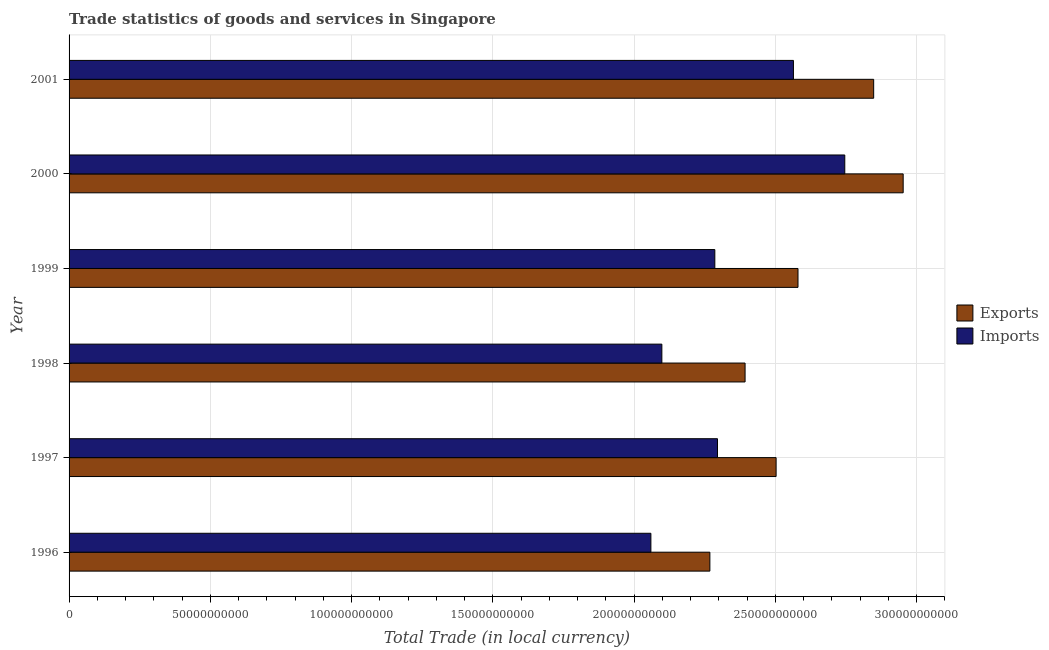How many different coloured bars are there?
Your answer should be very brief. 2. How many groups of bars are there?
Make the answer very short. 6. What is the imports of goods and services in 2000?
Ensure brevity in your answer.  2.75e+11. Across all years, what is the maximum export of goods and services?
Your response must be concise. 2.95e+11. Across all years, what is the minimum export of goods and services?
Offer a very short reply. 2.27e+11. In which year was the imports of goods and services maximum?
Your answer should be very brief. 2000. In which year was the imports of goods and services minimum?
Give a very brief answer. 1996. What is the total export of goods and services in the graph?
Your answer should be very brief. 1.55e+12. What is the difference between the imports of goods and services in 1998 and that in 2000?
Offer a very short reply. -6.47e+1. What is the difference between the imports of goods and services in 1999 and the export of goods and services in 1996?
Your response must be concise. 1.75e+09. What is the average export of goods and services per year?
Make the answer very short. 2.59e+11. In the year 1998, what is the difference between the imports of goods and services and export of goods and services?
Ensure brevity in your answer.  -2.95e+1. What is the ratio of the export of goods and services in 1998 to that in 2001?
Provide a succinct answer. 0.84. What is the difference between the highest and the second highest imports of goods and services?
Offer a very short reply. 1.82e+1. What is the difference between the highest and the lowest imports of goods and services?
Provide a succinct answer. 6.86e+1. In how many years, is the export of goods and services greater than the average export of goods and services taken over all years?
Provide a succinct answer. 2. Is the sum of the imports of goods and services in 1996 and 1997 greater than the maximum export of goods and services across all years?
Your answer should be compact. Yes. What does the 1st bar from the top in 2001 represents?
Offer a terse response. Imports. What does the 1st bar from the bottom in 2001 represents?
Provide a succinct answer. Exports. How many bars are there?
Make the answer very short. 12. Are all the bars in the graph horizontal?
Make the answer very short. Yes. What is the difference between two consecutive major ticks on the X-axis?
Offer a very short reply. 5.00e+1. Are the values on the major ticks of X-axis written in scientific E-notation?
Your answer should be very brief. No. Does the graph contain any zero values?
Offer a terse response. No. Does the graph contain grids?
Make the answer very short. Yes. How many legend labels are there?
Ensure brevity in your answer.  2. How are the legend labels stacked?
Make the answer very short. Vertical. What is the title of the graph?
Your answer should be very brief. Trade statistics of goods and services in Singapore. What is the label or title of the X-axis?
Offer a very short reply. Total Trade (in local currency). What is the Total Trade (in local currency) of Exports in 1996?
Provide a short and direct response. 2.27e+11. What is the Total Trade (in local currency) in Imports in 1996?
Your answer should be compact. 2.06e+11. What is the Total Trade (in local currency) in Exports in 1997?
Provide a succinct answer. 2.50e+11. What is the Total Trade (in local currency) in Imports in 1997?
Keep it short and to the point. 2.30e+11. What is the Total Trade (in local currency) of Exports in 1998?
Ensure brevity in your answer.  2.39e+11. What is the Total Trade (in local currency) in Imports in 1998?
Make the answer very short. 2.10e+11. What is the Total Trade (in local currency) in Exports in 1999?
Your response must be concise. 2.58e+11. What is the Total Trade (in local currency) of Imports in 1999?
Provide a short and direct response. 2.29e+11. What is the Total Trade (in local currency) of Exports in 2000?
Provide a short and direct response. 2.95e+11. What is the Total Trade (in local currency) of Imports in 2000?
Give a very brief answer. 2.75e+11. What is the Total Trade (in local currency) of Exports in 2001?
Offer a very short reply. 2.85e+11. What is the Total Trade (in local currency) in Imports in 2001?
Provide a short and direct response. 2.56e+11. Across all years, what is the maximum Total Trade (in local currency) of Exports?
Your response must be concise. 2.95e+11. Across all years, what is the maximum Total Trade (in local currency) in Imports?
Your response must be concise. 2.75e+11. Across all years, what is the minimum Total Trade (in local currency) in Exports?
Offer a terse response. 2.27e+11. Across all years, what is the minimum Total Trade (in local currency) in Imports?
Make the answer very short. 2.06e+11. What is the total Total Trade (in local currency) of Exports in the graph?
Keep it short and to the point. 1.55e+12. What is the total Total Trade (in local currency) in Imports in the graph?
Keep it short and to the point. 1.40e+12. What is the difference between the Total Trade (in local currency) in Exports in 1996 and that in 1997?
Offer a very short reply. -2.34e+1. What is the difference between the Total Trade (in local currency) in Imports in 1996 and that in 1997?
Provide a short and direct response. -2.36e+1. What is the difference between the Total Trade (in local currency) of Exports in 1996 and that in 1998?
Make the answer very short. -1.25e+1. What is the difference between the Total Trade (in local currency) in Imports in 1996 and that in 1998?
Provide a short and direct response. -3.88e+09. What is the difference between the Total Trade (in local currency) in Exports in 1996 and that in 1999?
Provide a short and direct response. -3.12e+1. What is the difference between the Total Trade (in local currency) in Imports in 1996 and that in 1999?
Make the answer very short. -2.26e+1. What is the difference between the Total Trade (in local currency) of Exports in 1996 and that in 2000?
Give a very brief answer. -6.84e+1. What is the difference between the Total Trade (in local currency) in Imports in 1996 and that in 2000?
Provide a short and direct response. -6.86e+1. What is the difference between the Total Trade (in local currency) of Exports in 1996 and that in 2001?
Make the answer very short. -5.80e+1. What is the difference between the Total Trade (in local currency) of Imports in 1996 and that in 2001?
Your answer should be very brief. -5.05e+1. What is the difference between the Total Trade (in local currency) in Exports in 1997 and that in 1998?
Provide a succinct answer. 1.10e+1. What is the difference between the Total Trade (in local currency) in Imports in 1997 and that in 1998?
Offer a very short reply. 1.97e+1. What is the difference between the Total Trade (in local currency) of Exports in 1997 and that in 1999?
Your answer should be compact. -7.75e+09. What is the difference between the Total Trade (in local currency) of Imports in 1997 and that in 1999?
Your answer should be compact. 9.42e+08. What is the difference between the Total Trade (in local currency) of Exports in 1997 and that in 2000?
Provide a short and direct response. -4.50e+1. What is the difference between the Total Trade (in local currency) in Imports in 1997 and that in 2000?
Provide a succinct answer. -4.51e+1. What is the difference between the Total Trade (in local currency) in Exports in 1997 and that in 2001?
Provide a short and direct response. -3.45e+1. What is the difference between the Total Trade (in local currency) of Imports in 1997 and that in 2001?
Offer a terse response. -2.69e+1. What is the difference between the Total Trade (in local currency) in Exports in 1998 and that in 1999?
Your response must be concise. -1.87e+1. What is the difference between the Total Trade (in local currency) of Imports in 1998 and that in 1999?
Your answer should be very brief. -1.87e+1. What is the difference between the Total Trade (in local currency) in Exports in 1998 and that in 2000?
Your answer should be compact. -5.60e+1. What is the difference between the Total Trade (in local currency) of Imports in 1998 and that in 2000?
Give a very brief answer. -6.47e+1. What is the difference between the Total Trade (in local currency) of Exports in 1998 and that in 2001?
Offer a very short reply. -4.55e+1. What is the difference between the Total Trade (in local currency) of Imports in 1998 and that in 2001?
Your response must be concise. -4.66e+1. What is the difference between the Total Trade (in local currency) in Exports in 1999 and that in 2000?
Provide a succinct answer. -3.72e+1. What is the difference between the Total Trade (in local currency) in Imports in 1999 and that in 2000?
Provide a succinct answer. -4.60e+1. What is the difference between the Total Trade (in local currency) of Exports in 1999 and that in 2001?
Your answer should be compact. -2.68e+1. What is the difference between the Total Trade (in local currency) in Imports in 1999 and that in 2001?
Keep it short and to the point. -2.78e+1. What is the difference between the Total Trade (in local currency) of Exports in 2000 and that in 2001?
Provide a short and direct response. 1.04e+1. What is the difference between the Total Trade (in local currency) of Imports in 2000 and that in 2001?
Your response must be concise. 1.82e+1. What is the difference between the Total Trade (in local currency) in Exports in 1996 and the Total Trade (in local currency) in Imports in 1997?
Offer a terse response. -2.70e+09. What is the difference between the Total Trade (in local currency) of Exports in 1996 and the Total Trade (in local currency) of Imports in 1998?
Provide a succinct answer. 1.70e+1. What is the difference between the Total Trade (in local currency) in Exports in 1996 and the Total Trade (in local currency) in Imports in 1999?
Provide a succinct answer. -1.75e+09. What is the difference between the Total Trade (in local currency) of Exports in 1996 and the Total Trade (in local currency) of Imports in 2000?
Offer a very short reply. -4.77e+1. What is the difference between the Total Trade (in local currency) of Exports in 1996 and the Total Trade (in local currency) of Imports in 2001?
Provide a short and direct response. -2.96e+1. What is the difference between the Total Trade (in local currency) in Exports in 1997 and the Total Trade (in local currency) in Imports in 1998?
Give a very brief answer. 4.04e+1. What is the difference between the Total Trade (in local currency) in Exports in 1997 and the Total Trade (in local currency) in Imports in 1999?
Ensure brevity in your answer.  2.17e+1. What is the difference between the Total Trade (in local currency) of Exports in 1997 and the Total Trade (in local currency) of Imports in 2000?
Your response must be concise. -2.43e+1. What is the difference between the Total Trade (in local currency) in Exports in 1997 and the Total Trade (in local currency) in Imports in 2001?
Keep it short and to the point. -6.13e+09. What is the difference between the Total Trade (in local currency) in Exports in 1998 and the Total Trade (in local currency) in Imports in 1999?
Provide a short and direct response. 1.07e+1. What is the difference between the Total Trade (in local currency) in Exports in 1998 and the Total Trade (in local currency) in Imports in 2000?
Provide a succinct answer. -3.53e+1. What is the difference between the Total Trade (in local currency) in Exports in 1998 and the Total Trade (in local currency) in Imports in 2001?
Provide a short and direct response. -1.71e+1. What is the difference between the Total Trade (in local currency) of Exports in 1999 and the Total Trade (in local currency) of Imports in 2000?
Provide a short and direct response. -1.66e+1. What is the difference between the Total Trade (in local currency) in Exports in 1999 and the Total Trade (in local currency) in Imports in 2001?
Keep it short and to the point. 1.62e+09. What is the difference between the Total Trade (in local currency) of Exports in 2000 and the Total Trade (in local currency) of Imports in 2001?
Give a very brief answer. 3.88e+1. What is the average Total Trade (in local currency) in Exports per year?
Ensure brevity in your answer.  2.59e+11. What is the average Total Trade (in local currency) of Imports per year?
Provide a succinct answer. 2.34e+11. In the year 1996, what is the difference between the Total Trade (in local currency) of Exports and Total Trade (in local currency) of Imports?
Ensure brevity in your answer.  2.09e+1. In the year 1997, what is the difference between the Total Trade (in local currency) in Exports and Total Trade (in local currency) in Imports?
Offer a very short reply. 2.07e+1. In the year 1998, what is the difference between the Total Trade (in local currency) of Exports and Total Trade (in local currency) of Imports?
Give a very brief answer. 2.95e+1. In the year 1999, what is the difference between the Total Trade (in local currency) of Exports and Total Trade (in local currency) of Imports?
Offer a very short reply. 2.94e+1. In the year 2000, what is the difference between the Total Trade (in local currency) in Exports and Total Trade (in local currency) in Imports?
Offer a very short reply. 2.07e+1. In the year 2001, what is the difference between the Total Trade (in local currency) of Exports and Total Trade (in local currency) of Imports?
Provide a succinct answer. 2.84e+1. What is the ratio of the Total Trade (in local currency) of Exports in 1996 to that in 1997?
Make the answer very short. 0.91. What is the ratio of the Total Trade (in local currency) in Imports in 1996 to that in 1997?
Your answer should be compact. 0.9. What is the ratio of the Total Trade (in local currency) in Exports in 1996 to that in 1998?
Keep it short and to the point. 0.95. What is the ratio of the Total Trade (in local currency) in Imports in 1996 to that in 1998?
Make the answer very short. 0.98. What is the ratio of the Total Trade (in local currency) in Exports in 1996 to that in 1999?
Ensure brevity in your answer.  0.88. What is the ratio of the Total Trade (in local currency) in Imports in 1996 to that in 1999?
Offer a terse response. 0.9. What is the ratio of the Total Trade (in local currency) of Exports in 1996 to that in 2000?
Ensure brevity in your answer.  0.77. What is the ratio of the Total Trade (in local currency) of Imports in 1996 to that in 2000?
Your response must be concise. 0.75. What is the ratio of the Total Trade (in local currency) of Exports in 1996 to that in 2001?
Your response must be concise. 0.8. What is the ratio of the Total Trade (in local currency) of Imports in 1996 to that in 2001?
Keep it short and to the point. 0.8. What is the ratio of the Total Trade (in local currency) of Exports in 1997 to that in 1998?
Your answer should be compact. 1.05. What is the ratio of the Total Trade (in local currency) of Imports in 1997 to that in 1998?
Offer a terse response. 1.09. What is the ratio of the Total Trade (in local currency) in Exports in 1997 to that in 1999?
Offer a terse response. 0.97. What is the ratio of the Total Trade (in local currency) in Exports in 1997 to that in 2000?
Give a very brief answer. 0.85. What is the ratio of the Total Trade (in local currency) of Imports in 1997 to that in 2000?
Give a very brief answer. 0.84. What is the ratio of the Total Trade (in local currency) of Exports in 1997 to that in 2001?
Ensure brevity in your answer.  0.88. What is the ratio of the Total Trade (in local currency) in Imports in 1997 to that in 2001?
Offer a very short reply. 0.9. What is the ratio of the Total Trade (in local currency) in Exports in 1998 to that in 1999?
Your answer should be very brief. 0.93. What is the ratio of the Total Trade (in local currency) of Imports in 1998 to that in 1999?
Provide a short and direct response. 0.92. What is the ratio of the Total Trade (in local currency) in Exports in 1998 to that in 2000?
Offer a very short reply. 0.81. What is the ratio of the Total Trade (in local currency) of Imports in 1998 to that in 2000?
Your answer should be very brief. 0.76. What is the ratio of the Total Trade (in local currency) of Exports in 1998 to that in 2001?
Ensure brevity in your answer.  0.84. What is the ratio of the Total Trade (in local currency) of Imports in 1998 to that in 2001?
Provide a succinct answer. 0.82. What is the ratio of the Total Trade (in local currency) of Exports in 1999 to that in 2000?
Offer a very short reply. 0.87. What is the ratio of the Total Trade (in local currency) in Imports in 1999 to that in 2000?
Make the answer very short. 0.83. What is the ratio of the Total Trade (in local currency) of Exports in 1999 to that in 2001?
Give a very brief answer. 0.91. What is the ratio of the Total Trade (in local currency) of Imports in 1999 to that in 2001?
Your answer should be very brief. 0.89. What is the ratio of the Total Trade (in local currency) in Exports in 2000 to that in 2001?
Offer a terse response. 1.04. What is the ratio of the Total Trade (in local currency) of Imports in 2000 to that in 2001?
Your answer should be very brief. 1.07. What is the difference between the highest and the second highest Total Trade (in local currency) of Exports?
Give a very brief answer. 1.04e+1. What is the difference between the highest and the second highest Total Trade (in local currency) in Imports?
Keep it short and to the point. 1.82e+1. What is the difference between the highest and the lowest Total Trade (in local currency) of Exports?
Your answer should be very brief. 6.84e+1. What is the difference between the highest and the lowest Total Trade (in local currency) in Imports?
Offer a very short reply. 6.86e+1. 